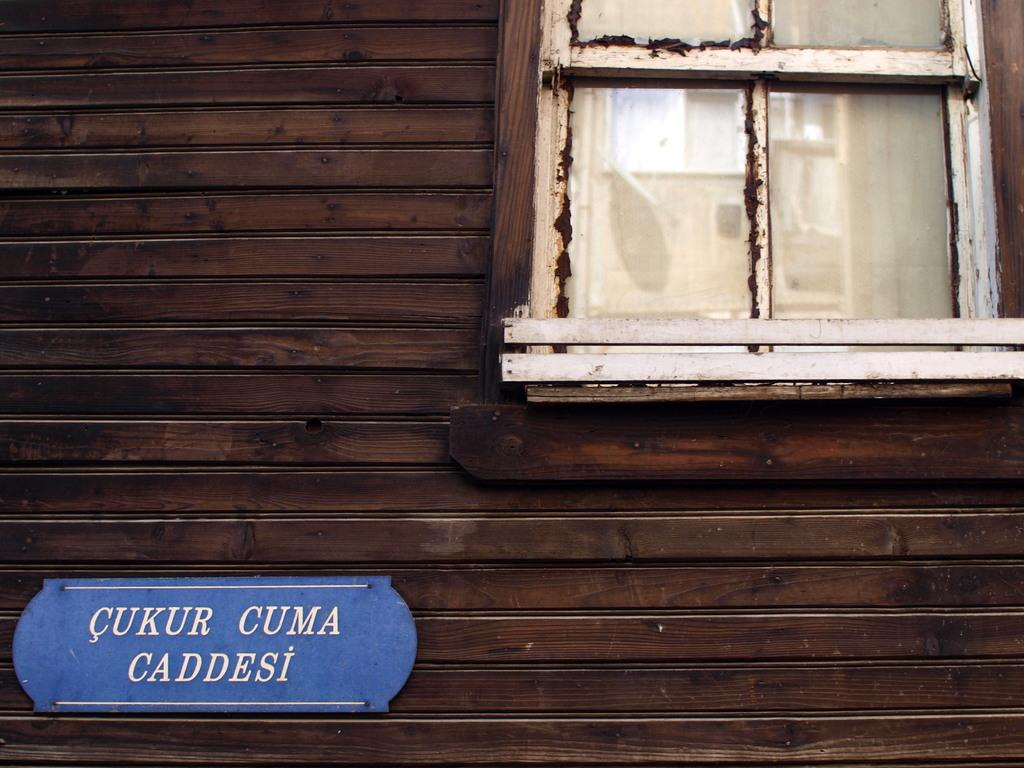What type of structure can be seen in the image? There is a wall in the image. What feature is present on the wall? The wall has a glass window. What else is visible on the wall? There is a board with text in the image. What type of drug can be seen being smoked near the airport in the image? There is no reference to a drug, smoking, or an airport in the image, so it is not possible to answer that question. 